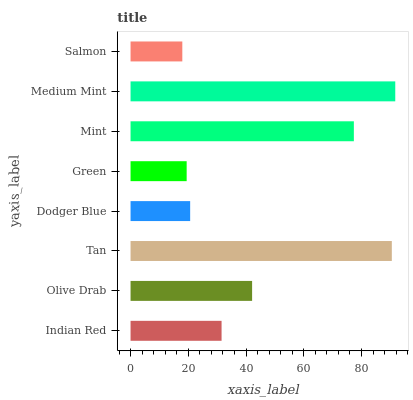Is Salmon the minimum?
Answer yes or no. Yes. Is Medium Mint the maximum?
Answer yes or no. Yes. Is Olive Drab the minimum?
Answer yes or no. No. Is Olive Drab the maximum?
Answer yes or no. No. Is Olive Drab greater than Indian Red?
Answer yes or no. Yes. Is Indian Red less than Olive Drab?
Answer yes or no. Yes. Is Indian Red greater than Olive Drab?
Answer yes or no. No. Is Olive Drab less than Indian Red?
Answer yes or no. No. Is Olive Drab the high median?
Answer yes or no. Yes. Is Indian Red the low median?
Answer yes or no. Yes. Is Tan the high median?
Answer yes or no. No. Is Tan the low median?
Answer yes or no. No. 